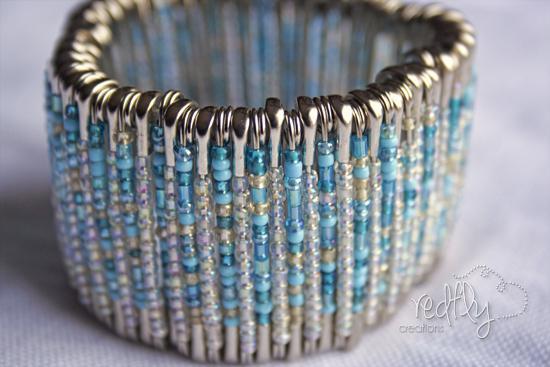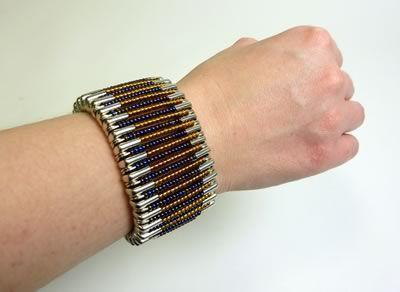The first image is the image on the left, the second image is the image on the right. Given the left and right images, does the statement "There are multiple pieces of jewelry on a woman’s arm that are not just gold colored." hold true? Answer yes or no. No. The first image is the image on the left, the second image is the image on the right. Evaluate the accuracy of this statement regarding the images: "The image on the right contains a bracelet with green beads on it.". Is it true? Answer yes or no. No. 